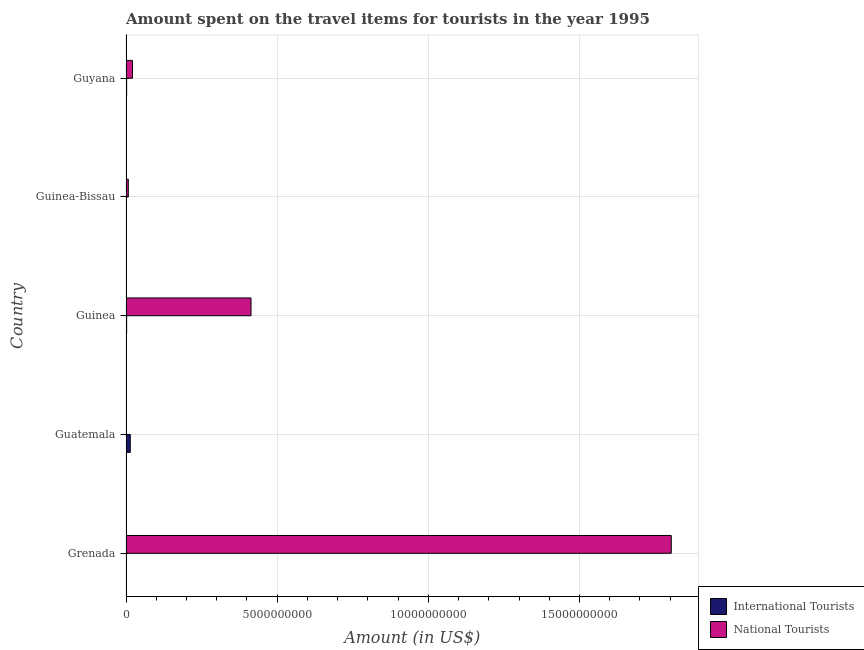How many groups of bars are there?
Provide a short and direct response. 5. Are the number of bars on each tick of the Y-axis equal?
Provide a succinct answer. Yes. What is the label of the 5th group of bars from the top?
Your answer should be compact. Grenada. What is the amount spent on travel items of national tourists in Guinea?
Your answer should be compact. 4.14e+09. Across all countries, what is the maximum amount spent on travel items of international tourists?
Provide a succinct answer. 1.41e+08. Across all countries, what is the minimum amount spent on travel items of international tourists?
Ensure brevity in your answer.  3.80e+06. In which country was the amount spent on travel items of national tourists maximum?
Provide a short and direct response. Grenada. In which country was the amount spent on travel items of international tourists minimum?
Make the answer very short. Guinea-Bissau. What is the total amount spent on travel items of national tourists in the graph?
Your answer should be very brief. 2.25e+1. What is the difference between the amount spent on travel items of international tourists in Guinea and that in Guinea-Bissau?
Keep it short and to the point. 1.72e+07. What is the difference between the amount spent on travel items of international tourists in Guyana and the amount spent on travel items of national tourists in Guinea-Bissau?
Offer a terse response. -5.50e+07. What is the average amount spent on travel items of international tourists per country?
Offer a terse response. 3.84e+07. What is the difference between the amount spent on travel items of international tourists and amount spent on travel items of national tourists in Guatemala?
Provide a short and direct response. 1.30e+08. In how many countries, is the amount spent on travel items of international tourists greater than 15000000000 US$?
Give a very brief answer. 0. What is the ratio of the amount spent on travel items of international tourists in Guinea-Bissau to that in Guyana?
Provide a short and direct response. 0.18. Is the amount spent on travel items of national tourists in Guinea less than that in Guyana?
Ensure brevity in your answer.  No. Is the difference between the amount spent on travel items of international tourists in Grenada and Guinea-Bissau greater than the difference between the amount spent on travel items of national tourists in Grenada and Guinea-Bissau?
Give a very brief answer. No. What is the difference between the highest and the second highest amount spent on travel items of national tourists?
Offer a very short reply. 1.39e+1. What is the difference between the highest and the lowest amount spent on travel items of national tourists?
Offer a very short reply. 1.80e+1. Is the sum of the amount spent on travel items of national tourists in Grenada and Guinea greater than the maximum amount spent on travel items of international tourists across all countries?
Offer a very short reply. Yes. What does the 2nd bar from the top in Guatemala represents?
Offer a very short reply. International Tourists. What does the 2nd bar from the bottom in Guatemala represents?
Make the answer very short. National Tourists. How many countries are there in the graph?
Keep it short and to the point. 5. What is the difference between two consecutive major ticks on the X-axis?
Keep it short and to the point. 5.00e+09. Where does the legend appear in the graph?
Ensure brevity in your answer.  Bottom right. What is the title of the graph?
Keep it short and to the point. Amount spent on the travel items for tourists in the year 1995. Does "Start a business" appear as one of the legend labels in the graph?
Ensure brevity in your answer.  No. What is the label or title of the Y-axis?
Offer a terse response. Country. What is the Amount (in US$) of National Tourists in Grenada?
Your answer should be compact. 1.80e+1. What is the Amount (in US$) of International Tourists in Guatemala?
Ensure brevity in your answer.  1.41e+08. What is the Amount (in US$) of National Tourists in Guatemala?
Keep it short and to the point. 1.10e+07. What is the Amount (in US$) in International Tourists in Guinea?
Provide a succinct answer. 2.10e+07. What is the Amount (in US$) in National Tourists in Guinea?
Offer a terse response. 4.14e+09. What is the Amount (in US$) in International Tourists in Guinea-Bissau?
Provide a short and direct response. 3.80e+06. What is the Amount (in US$) in National Tourists in Guinea-Bissau?
Offer a very short reply. 7.60e+07. What is the Amount (in US$) in International Tourists in Guyana?
Give a very brief answer. 2.10e+07. What is the Amount (in US$) of National Tourists in Guyana?
Give a very brief answer. 2.13e+08. Across all countries, what is the maximum Amount (in US$) in International Tourists?
Give a very brief answer. 1.41e+08. Across all countries, what is the maximum Amount (in US$) in National Tourists?
Your answer should be very brief. 1.80e+1. Across all countries, what is the minimum Amount (in US$) of International Tourists?
Offer a terse response. 3.80e+06. Across all countries, what is the minimum Amount (in US$) in National Tourists?
Your answer should be compact. 1.10e+07. What is the total Amount (in US$) in International Tourists in the graph?
Provide a short and direct response. 1.92e+08. What is the total Amount (in US$) of National Tourists in the graph?
Your answer should be compact. 2.25e+1. What is the difference between the Amount (in US$) in International Tourists in Grenada and that in Guatemala?
Give a very brief answer. -1.36e+08. What is the difference between the Amount (in US$) in National Tourists in Grenada and that in Guatemala?
Keep it short and to the point. 1.80e+1. What is the difference between the Amount (in US$) of International Tourists in Grenada and that in Guinea?
Make the answer very short. -1.60e+07. What is the difference between the Amount (in US$) of National Tourists in Grenada and that in Guinea?
Give a very brief answer. 1.39e+1. What is the difference between the Amount (in US$) in International Tourists in Grenada and that in Guinea-Bissau?
Provide a short and direct response. 1.20e+06. What is the difference between the Amount (in US$) in National Tourists in Grenada and that in Guinea-Bissau?
Your answer should be compact. 1.80e+1. What is the difference between the Amount (in US$) of International Tourists in Grenada and that in Guyana?
Your answer should be compact. -1.60e+07. What is the difference between the Amount (in US$) of National Tourists in Grenada and that in Guyana?
Your answer should be compact. 1.78e+1. What is the difference between the Amount (in US$) of International Tourists in Guatemala and that in Guinea?
Ensure brevity in your answer.  1.20e+08. What is the difference between the Amount (in US$) of National Tourists in Guatemala and that in Guinea?
Your answer should be very brief. -4.12e+09. What is the difference between the Amount (in US$) in International Tourists in Guatemala and that in Guinea-Bissau?
Make the answer very short. 1.37e+08. What is the difference between the Amount (in US$) in National Tourists in Guatemala and that in Guinea-Bissau?
Keep it short and to the point. -6.50e+07. What is the difference between the Amount (in US$) of International Tourists in Guatemala and that in Guyana?
Provide a short and direct response. 1.20e+08. What is the difference between the Amount (in US$) in National Tourists in Guatemala and that in Guyana?
Keep it short and to the point. -2.02e+08. What is the difference between the Amount (in US$) of International Tourists in Guinea and that in Guinea-Bissau?
Offer a terse response. 1.72e+07. What is the difference between the Amount (in US$) of National Tourists in Guinea and that in Guinea-Bissau?
Your answer should be compact. 4.06e+09. What is the difference between the Amount (in US$) of International Tourists in Guinea and that in Guyana?
Offer a very short reply. 0. What is the difference between the Amount (in US$) of National Tourists in Guinea and that in Guyana?
Offer a terse response. 3.92e+09. What is the difference between the Amount (in US$) of International Tourists in Guinea-Bissau and that in Guyana?
Your answer should be compact. -1.72e+07. What is the difference between the Amount (in US$) of National Tourists in Guinea-Bissau and that in Guyana?
Make the answer very short. -1.37e+08. What is the difference between the Amount (in US$) in International Tourists in Grenada and the Amount (in US$) in National Tourists in Guatemala?
Give a very brief answer. -6.00e+06. What is the difference between the Amount (in US$) in International Tourists in Grenada and the Amount (in US$) in National Tourists in Guinea?
Ensure brevity in your answer.  -4.13e+09. What is the difference between the Amount (in US$) of International Tourists in Grenada and the Amount (in US$) of National Tourists in Guinea-Bissau?
Provide a short and direct response. -7.10e+07. What is the difference between the Amount (in US$) in International Tourists in Grenada and the Amount (in US$) in National Tourists in Guyana?
Offer a terse response. -2.08e+08. What is the difference between the Amount (in US$) in International Tourists in Guatemala and the Amount (in US$) in National Tourists in Guinea?
Your answer should be compact. -3.99e+09. What is the difference between the Amount (in US$) of International Tourists in Guatemala and the Amount (in US$) of National Tourists in Guinea-Bissau?
Your response must be concise. 6.50e+07. What is the difference between the Amount (in US$) in International Tourists in Guatemala and the Amount (in US$) in National Tourists in Guyana?
Keep it short and to the point. -7.20e+07. What is the difference between the Amount (in US$) of International Tourists in Guinea and the Amount (in US$) of National Tourists in Guinea-Bissau?
Keep it short and to the point. -5.50e+07. What is the difference between the Amount (in US$) of International Tourists in Guinea and the Amount (in US$) of National Tourists in Guyana?
Your answer should be compact. -1.92e+08. What is the difference between the Amount (in US$) of International Tourists in Guinea-Bissau and the Amount (in US$) of National Tourists in Guyana?
Provide a succinct answer. -2.09e+08. What is the average Amount (in US$) in International Tourists per country?
Ensure brevity in your answer.  3.84e+07. What is the average Amount (in US$) of National Tourists per country?
Keep it short and to the point. 4.49e+09. What is the difference between the Amount (in US$) of International Tourists and Amount (in US$) of National Tourists in Grenada?
Ensure brevity in your answer.  -1.80e+1. What is the difference between the Amount (in US$) of International Tourists and Amount (in US$) of National Tourists in Guatemala?
Make the answer very short. 1.30e+08. What is the difference between the Amount (in US$) in International Tourists and Amount (in US$) in National Tourists in Guinea?
Give a very brief answer. -4.11e+09. What is the difference between the Amount (in US$) in International Tourists and Amount (in US$) in National Tourists in Guinea-Bissau?
Make the answer very short. -7.22e+07. What is the difference between the Amount (in US$) in International Tourists and Amount (in US$) in National Tourists in Guyana?
Offer a terse response. -1.92e+08. What is the ratio of the Amount (in US$) of International Tourists in Grenada to that in Guatemala?
Offer a terse response. 0.04. What is the ratio of the Amount (in US$) of National Tourists in Grenada to that in Guatemala?
Keep it short and to the point. 1639.64. What is the ratio of the Amount (in US$) in International Tourists in Grenada to that in Guinea?
Keep it short and to the point. 0.24. What is the ratio of the Amount (in US$) in National Tourists in Grenada to that in Guinea?
Provide a succinct answer. 4.36. What is the ratio of the Amount (in US$) of International Tourists in Grenada to that in Guinea-Bissau?
Keep it short and to the point. 1.32. What is the ratio of the Amount (in US$) in National Tourists in Grenada to that in Guinea-Bissau?
Provide a short and direct response. 237.32. What is the ratio of the Amount (in US$) in International Tourists in Grenada to that in Guyana?
Provide a short and direct response. 0.24. What is the ratio of the Amount (in US$) of National Tourists in Grenada to that in Guyana?
Provide a short and direct response. 84.68. What is the ratio of the Amount (in US$) in International Tourists in Guatemala to that in Guinea?
Ensure brevity in your answer.  6.71. What is the ratio of the Amount (in US$) of National Tourists in Guatemala to that in Guinea?
Provide a succinct answer. 0. What is the ratio of the Amount (in US$) in International Tourists in Guatemala to that in Guinea-Bissau?
Provide a succinct answer. 37.11. What is the ratio of the Amount (in US$) in National Tourists in Guatemala to that in Guinea-Bissau?
Keep it short and to the point. 0.14. What is the ratio of the Amount (in US$) of International Tourists in Guatemala to that in Guyana?
Provide a succinct answer. 6.71. What is the ratio of the Amount (in US$) in National Tourists in Guatemala to that in Guyana?
Offer a very short reply. 0.05. What is the ratio of the Amount (in US$) of International Tourists in Guinea to that in Guinea-Bissau?
Your response must be concise. 5.53. What is the ratio of the Amount (in US$) of National Tourists in Guinea to that in Guinea-Bissau?
Keep it short and to the point. 54.41. What is the ratio of the Amount (in US$) in National Tourists in Guinea to that in Guyana?
Offer a very short reply. 19.41. What is the ratio of the Amount (in US$) in International Tourists in Guinea-Bissau to that in Guyana?
Your answer should be very brief. 0.18. What is the ratio of the Amount (in US$) in National Tourists in Guinea-Bissau to that in Guyana?
Make the answer very short. 0.36. What is the difference between the highest and the second highest Amount (in US$) in International Tourists?
Your answer should be very brief. 1.20e+08. What is the difference between the highest and the second highest Amount (in US$) in National Tourists?
Provide a succinct answer. 1.39e+1. What is the difference between the highest and the lowest Amount (in US$) in International Tourists?
Your response must be concise. 1.37e+08. What is the difference between the highest and the lowest Amount (in US$) of National Tourists?
Provide a succinct answer. 1.80e+1. 